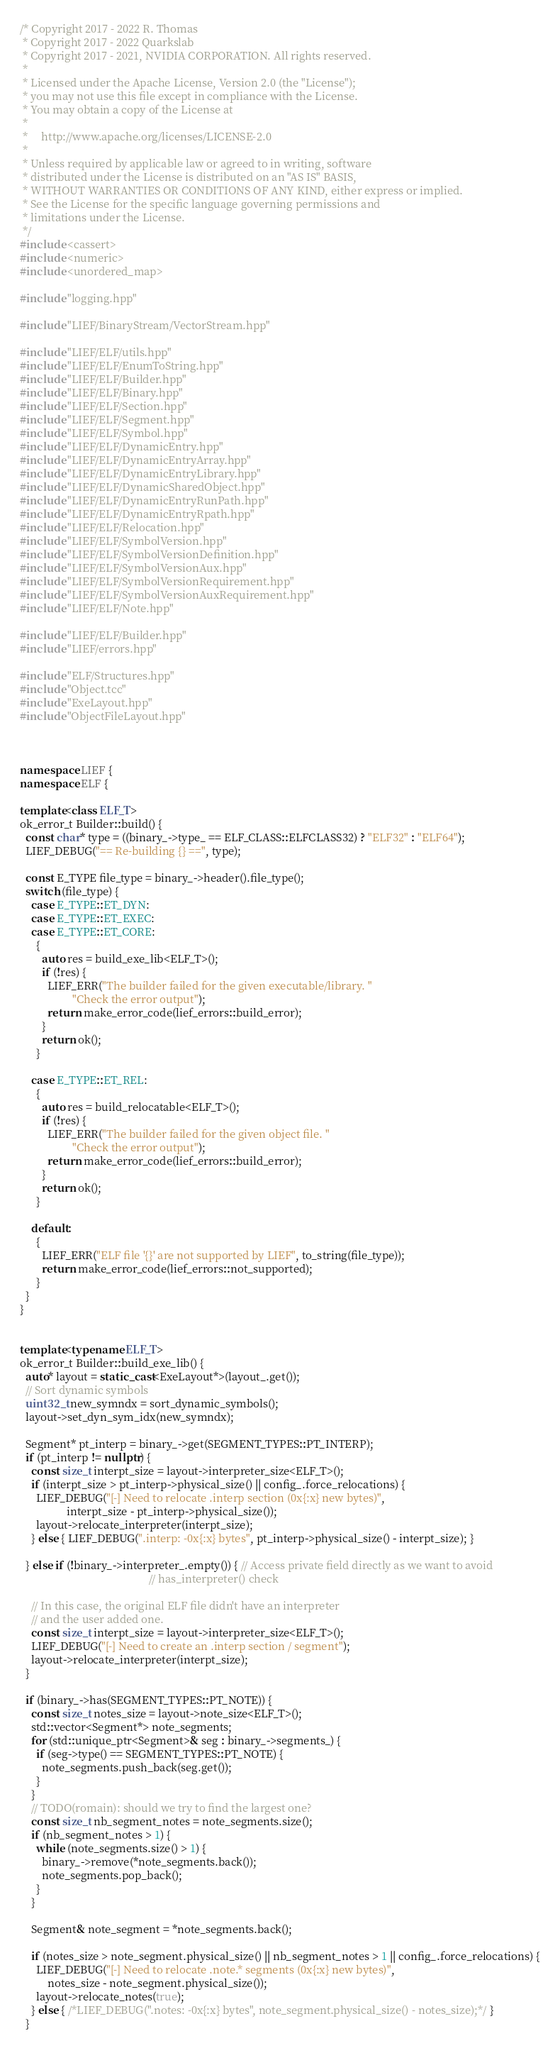<code> <loc_0><loc_0><loc_500><loc_500><_C++_>/* Copyright 2017 - 2022 R. Thomas
 * Copyright 2017 - 2022 Quarkslab
 * Copyright 2017 - 2021, NVIDIA CORPORATION. All rights reserved.
 *
 * Licensed under the Apache License, Version 2.0 (the "License");
 * you may not use this file except in compliance with the License.
 * You may obtain a copy of the License at
 *
 *     http://www.apache.org/licenses/LICENSE-2.0
 *
 * Unless required by applicable law or agreed to in writing, software
 * distributed under the License is distributed on an "AS IS" BASIS,
 * WITHOUT WARRANTIES OR CONDITIONS OF ANY KIND, either express or implied.
 * See the License for the specific language governing permissions and
 * limitations under the License.
 */
#include <cassert>
#include <numeric>
#include <unordered_map>

#include "logging.hpp"

#include "LIEF/BinaryStream/VectorStream.hpp"

#include "LIEF/ELF/utils.hpp"
#include "LIEF/ELF/EnumToString.hpp"
#include "LIEF/ELF/Builder.hpp"
#include "LIEF/ELF/Binary.hpp"
#include "LIEF/ELF/Section.hpp"
#include "LIEF/ELF/Segment.hpp"
#include "LIEF/ELF/Symbol.hpp"
#include "LIEF/ELF/DynamicEntry.hpp"
#include "LIEF/ELF/DynamicEntryArray.hpp"
#include "LIEF/ELF/DynamicEntryLibrary.hpp"
#include "LIEF/ELF/DynamicSharedObject.hpp"
#include "LIEF/ELF/DynamicEntryRunPath.hpp"
#include "LIEF/ELF/DynamicEntryRpath.hpp"
#include "LIEF/ELF/Relocation.hpp"
#include "LIEF/ELF/SymbolVersion.hpp"
#include "LIEF/ELF/SymbolVersionDefinition.hpp"
#include "LIEF/ELF/SymbolVersionAux.hpp"
#include "LIEF/ELF/SymbolVersionRequirement.hpp"
#include "LIEF/ELF/SymbolVersionAuxRequirement.hpp"
#include "LIEF/ELF/Note.hpp"

#include "LIEF/ELF/Builder.hpp"
#include "LIEF/errors.hpp"

#include "ELF/Structures.hpp"
#include "Object.tcc"
#include "ExeLayout.hpp"
#include "ObjectFileLayout.hpp"



namespace LIEF {
namespace ELF {

template<class ELF_T>
ok_error_t Builder::build() {
  const char* type = ((binary_->type_ == ELF_CLASS::ELFCLASS32) ? "ELF32" : "ELF64");
  LIEF_DEBUG("== Re-building {} ==", type);

  const E_TYPE file_type = binary_->header().file_type();
  switch (file_type) {
    case E_TYPE::ET_DYN:
    case E_TYPE::ET_EXEC:
    case E_TYPE::ET_CORE:
      {
        auto res = build_exe_lib<ELF_T>();
        if (!res) {
          LIEF_ERR("The builder failed for the given executable/library. "
                   "Check the error output");
          return make_error_code(lief_errors::build_error);
        }
        return ok();
      }

    case E_TYPE::ET_REL:
      {
        auto res = build_relocatable<ELF_T>();
        if (!res) {
          LIEF_ERR("The builder failed for the given object file. "
                   "Check the error output");
          return make_error_code(lief_errors::build_error);
        }
        return ok();
      }

    default:
      {
        LIEF_ERR("ELF file '{}' are not supported by LIEF", to_string(file_type));
        return make_error_code(lief_errors::not_supported);
      }
  }
}


template<typename ELF_T>
ok_error_t Builder::build_exe_lib() {
  auto* layout = static_cast<ExeLayout*>(layout_.get());
  // Sort dynamic symbols
  uint32_t new_symndx = sort_dynamic_symbols();
  layout->set_dyn_sym_idx(new_symndx);

  Segment* pt_interp = binary_->get(SEGMENT_TYPES::PT_INTERP);
  if (pt_interp != nullptr) {
    const size_t interpt_size = layout->interpreter_size<ELF_T>();
    if (interpt_size > pt_interp->physical_size() || config_.force_relocations) {
      LIEF_DEBUG("[-] Need to relocate .interp section (0x{:x} new bytes)",
                 interpt_size - pt_interp->physical_size());
      layout->relocate_interpreter(interpt_size);
    } else { LIEF_DEBUG(".interp: -0x{:x} bytes", pt_interp->physical_size() - interpt_size); }

  } else if (!binary_->interpreter_.empty()) { // Access private field directly as we want to avoid
                                               // has_interpreter() check

    // In this case, the original ELF file didn't have an interpreter
    // and the user added one.
    const size_t interpt_size = layout->interpreter_size<ELF_T>();
    LIEF_DEBUG("[-] Need to create an .interp section / segment");
    layout->relocate_interpreter(interpt_size);
  }

  if (binary_->has(SEGMENT_TYPES::PT_NOTE)) {
    const size_t notes_size = layout->note_size<ELF_T>();
    std::vector<Segment*> note_segments;
    for (std::unique_ptr<Segment>& seg : binary_->segments_) {
      if (seg->type() == SEGMENT_TYPES::PT_NOTE) {
        note_segments.push_back(seg.get());
      }
    }
    // TODO(romain): should we try to find the largest one?
    const size_t nb_segment_notes = note_segments.size();
    if (nb_segment_notes > 1) {
      while (note_segments.size() > 1) {
        binary_->remove(*note_segments.back());
        note_segments.pop_back();
      }
    }

    Segment& note_segment = *note_segments.back();

    if (notes_size > note_segment.physical_size() || nb_segment_notes > 1 || config_.force_relocations) {
      LIEF_DEBUG("[-] Need to relocate .note.* segments (0x{:x} new bytes)",
          notes_size - note_segment.physical_size());
      layout->relocate_notes(true);
    } else { /*LIEF_DEBUG(".notes: -0x{:x} bytes", note_segment.physical_size() - notes_size);*/ }
  }
</code> 